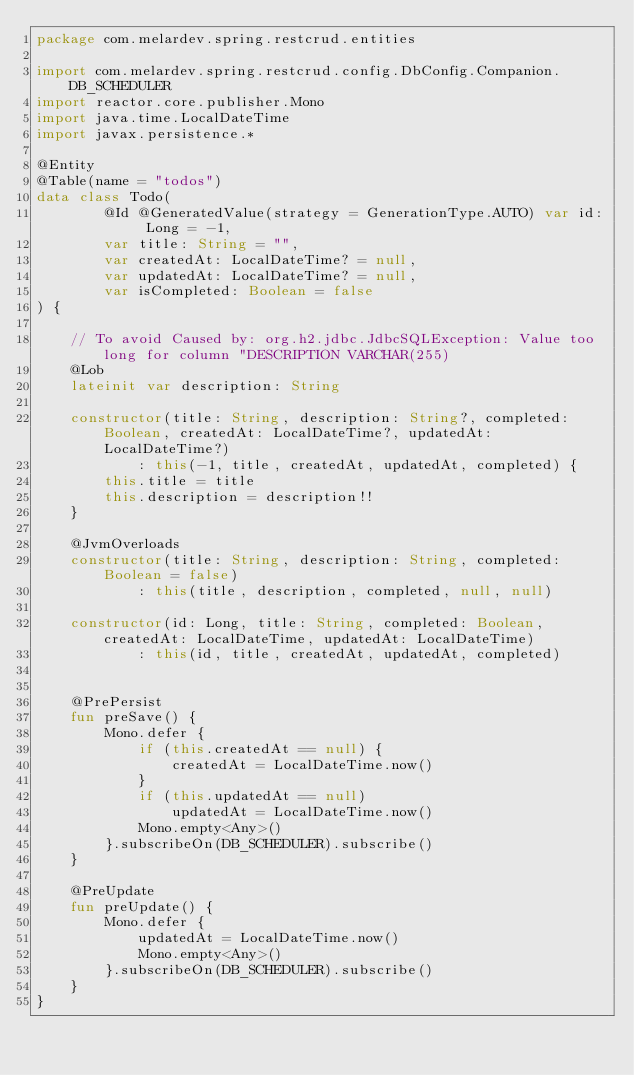Convert code to text. <code><loc_0><loc_0><loc_500><loc_500><_Kotlin_>package com.melardev.spring.restcrud.entities

import com.melardev.spring.restcrud.config.DbConfig.Companion.DB_SCHEDULER
import reactor.core.publisher.Mono
import java.time.LocalDateTime
import javax.persistence.*

@Entity
@Table(name = "todos")
data class Todo(
        @Id @GeneratedValue(strategy = GenerationType.AUTO) var id: Long = -1,
        var title: String = "",
        var createdAt: LocalDateTime? = null,
        var updatedAt: LocalDateTime? = null,
        var isCompleted: Boolean = false
) {

    // To avoid Caused by: org.h2.jdbc.JdbcSQLException: Value too long for column "DESCRIPTION VARCHAR(255)
    @Lob
    lateinit var description: String

    constructor(title: String, description: String?, completed: Boolean, createdAt: LocalDateTime?, updatedAt: LocalDateTime?)
            : this(-1, title, createdAt, updatedAt, completed) {
        this.title = title
        this.description = description!!
    }

    @JvmOverloads
    constructor(title: String, description: String, completed: Boolean = false)
            : this(title, description, completed, null, null)

    constructor(id: Long, title: String, completed: Boolean, createdAt: LocalDateTime, updatedAt: LocalDateTime)
            : this(id, title, createdAt, updatedAt, completed)


    @PrePersist
    fun preSave() {
        Mono.defer {
            if (this.createdAt == null) {
                createdAt = LocalDateTime.now()
            }
            if (this.updatedAt == null)
                updatedAt = LocalDateTime.now()
            Mono.empty<Any>()
        }.subscribeOn(DB_SCHEDULER).subscribe()
    }

    @PreUpdate
    fun preUpdate() {
        Mono.defer {
            updatedAt = LocalDateTime.now()
            Mono.empty<Any>()
        }.subscribeOn(DB_SCHEDULER).subscribe()
    }
}</code> 